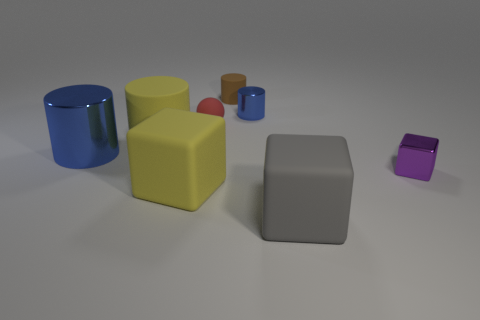Add 1 large cylinders. How many objects exist? 9 Subtract all blue cylinders. How many cylinders are left? 2 Subtract all large rubber cubes. How many cubes are left? 1 Subtract 1 brown cylinders. How many objects are left? 7 Subtract all blocks. How many objects are left? 5 Subtract 1 cylinders. How many cylinders are left? 3 Subtract all brown blocks. Subtract all yellow balls. How many blocks are left? 3 Subtract all gray cubes. How many cyan balls are left? 0 Subtract all small brown things. Subtract all big gray rubber blocks. How many objects are left? 6 Add 5 brown things. How many brown things are left? 6 